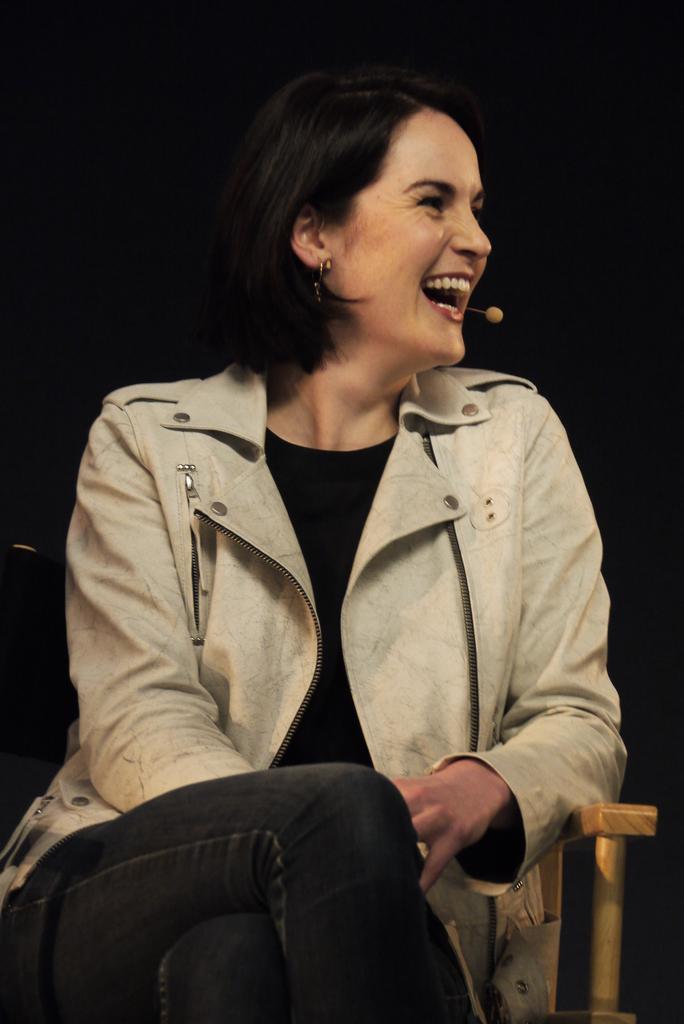How would you summarize this image in a sentence or two? In this image we can see a lady with mic. And she is sitting on a chair. In the background it is dark. 